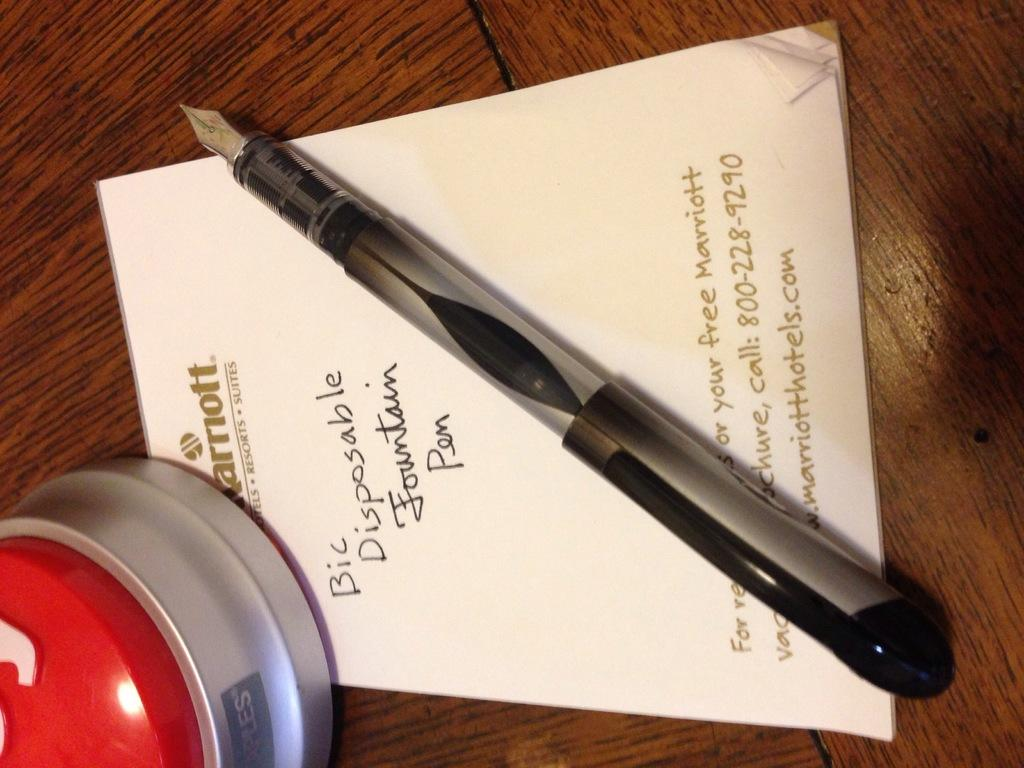What type of table is in the image? There is a wooden table in the image. What writing instrument is on the table? A ball pen is present on the table. What else is on the table besides the ball pen? There are papers on the table. Can you describe the content of the papers? Text is visible on the papers. What is the unspecified object on the table? The fact does not specify the object, so we cannot describe it. Is there a basketball game happening on the table in the image? No, there is no basketball game or any reference to basketball in the image. 